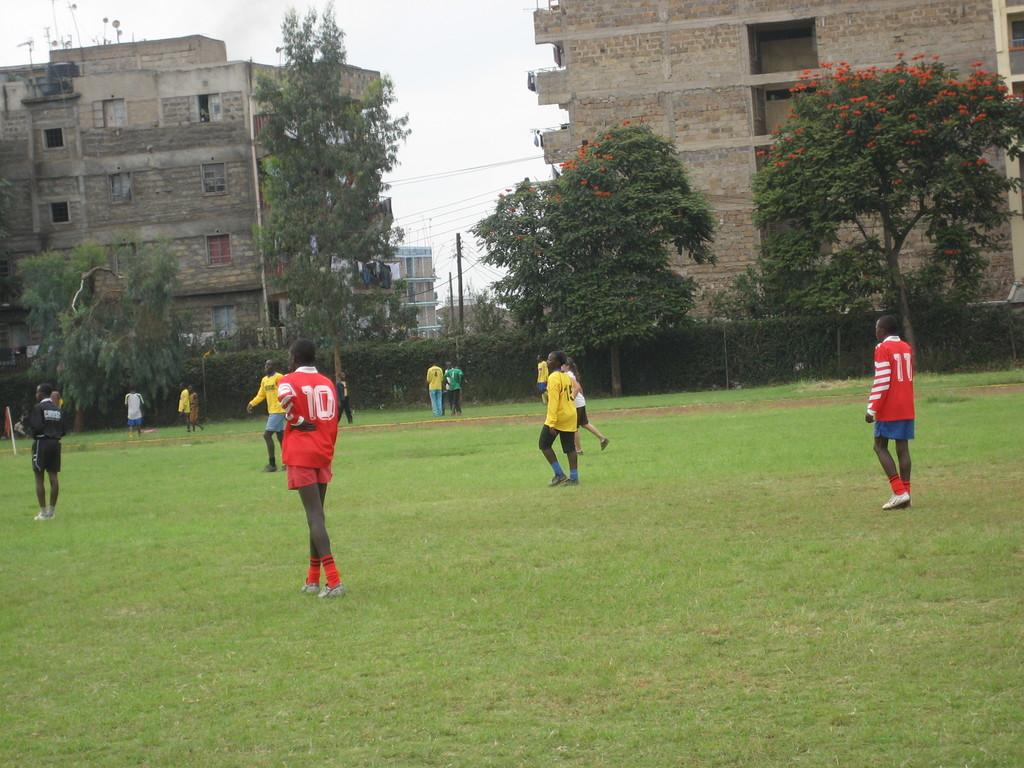What are the people in the image doing? The people in the image are playing on the grass. What can be seen surrounding the grassy area? There is fencing visible in the image. What type of natural elements are present in the image? There are trees in the image. What type of man-made structures can be seen in the image? There are buildings in the image. What type of toothbrush is being used by the people playing on the grass? There is no toothbrush present in the image, as the people are playing on the grass and not brushing their teeth. 